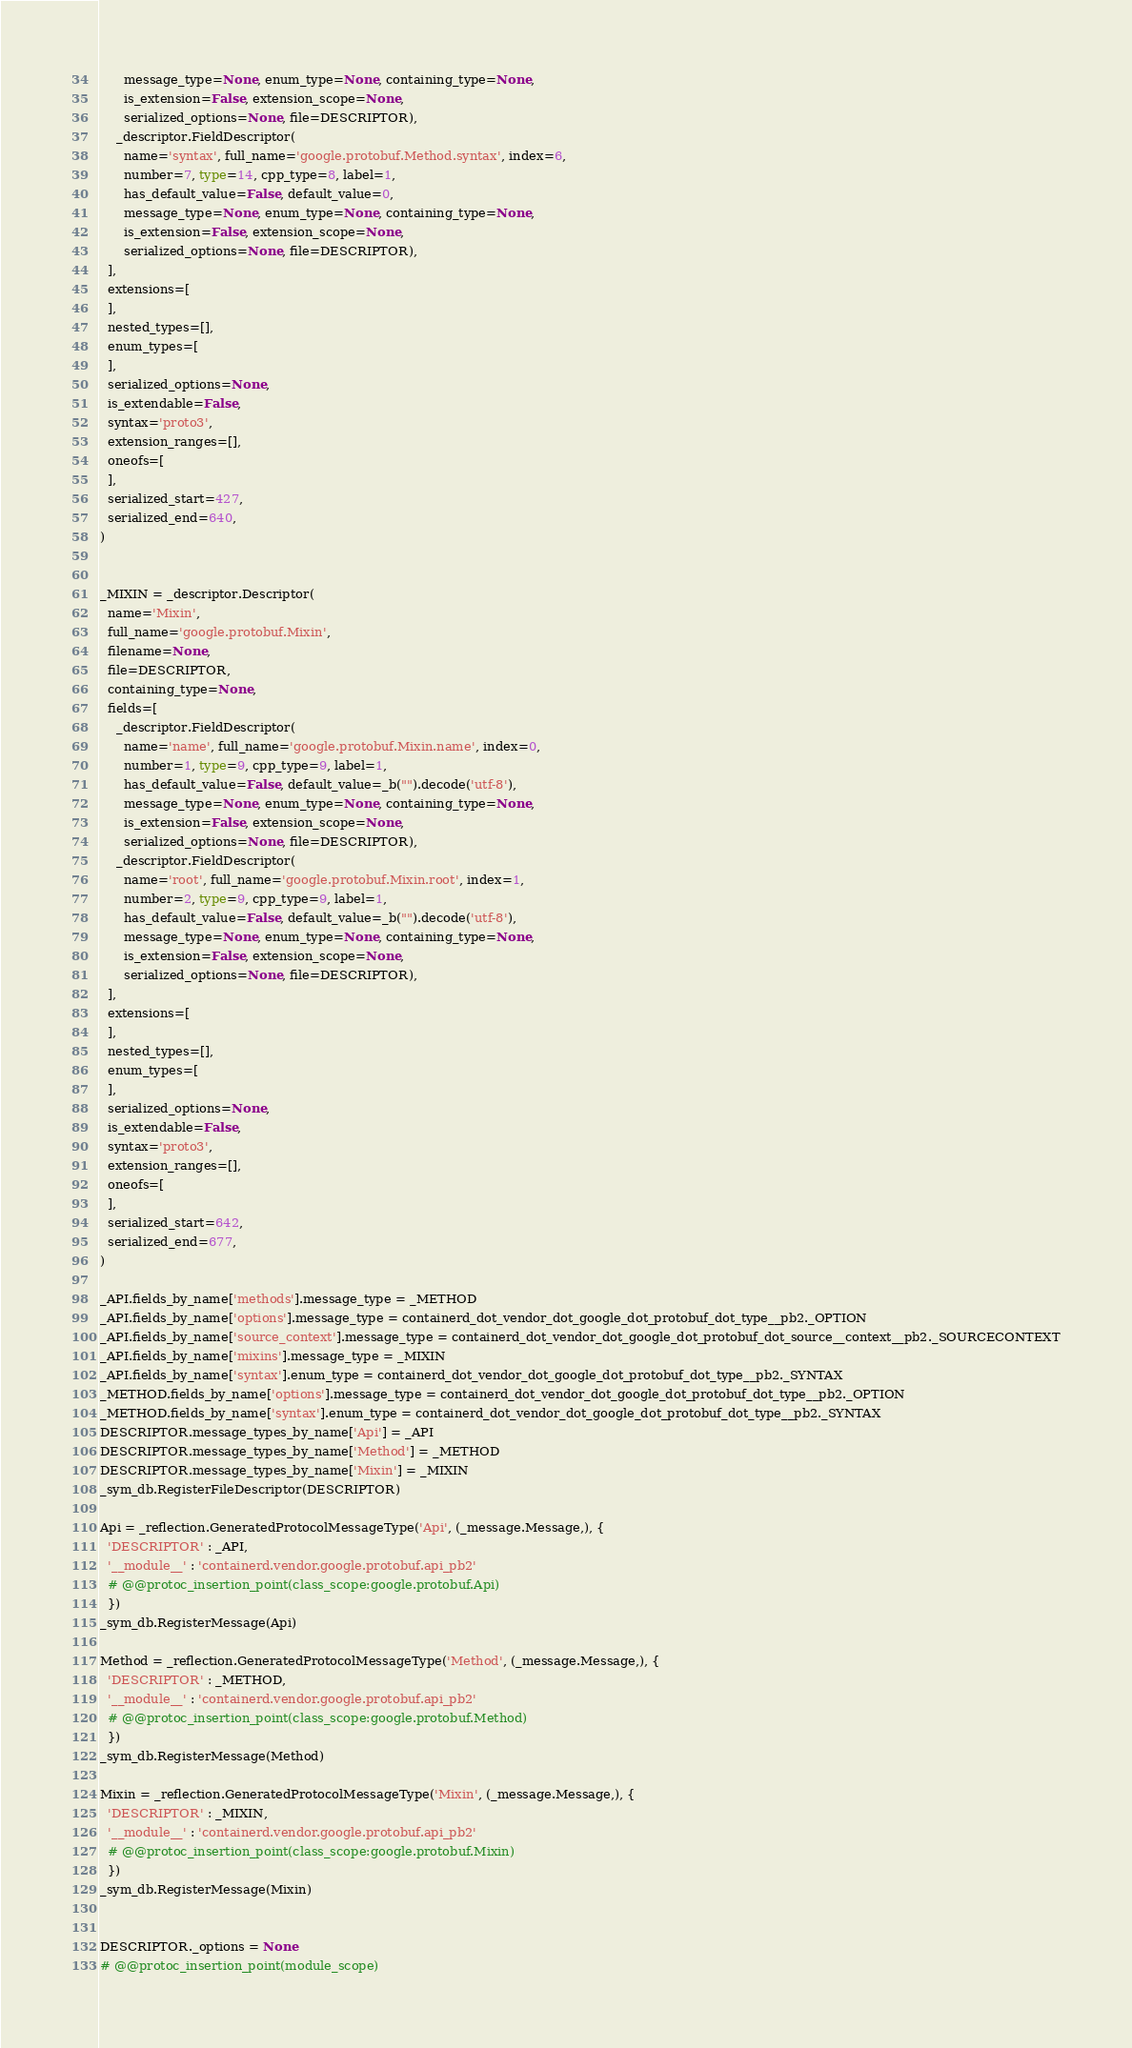Convert code to text. <code><loc_0><loc_0><loc_500><loc_500><_Python_>      message_type=None, enum_type=None, containing_type=None,
      is_extension=False, extension_scope=None,
      serialized_options=None, file=DESCRIPTOR),
    _descriptor.FieldDescriptor(
      name='syntax', full_name='google.protobuf.Method.syntax', index=6,
      number=7, type=14, cpp_type=8, label=1,
      has_default_value=False, default_value=0,
      message_type=None, enum_type=None, containing_type=None,
      is_extension=False, extension_scope=None,
      serialized_options=None, file=DESCRIPTOR),
  ],
  extensions=[
  ],
  nested_types=[],
  enum_types=[
  ],
  serialized_options=None,
  is_extendable=False,
  syntax='proto3',
  extension_ranges=[],
  oneofs=[
  ],
  serialized_start=427,
  serialized_end=640,
)


_MIXIN = _descriptor.Descriptor(
  name='Mixin',
  full_name='google.protobuf.Mixin',
  filename=None,
  file=DESCRIPTOR,
  containing_type=None,
  fields=[
    _descriptor.FieldDescriptor(
      name='name', full_name='google.protobuf.Mixin.name', index=0,
      number=1, type=9, cpp_type=9, label=1,
      has_default_value=False, default_value=_b("").decode('utf-8'),
      message_type=None, enum_type=None, containing_type=None,
      is_extension=False, extension_scope=None,
      serialized_options=None, file=DESCRIPTOR),
    _descriptor.FieldDescriptor(
      name='root', full_name='google.protobuf.Mixin.root', index=1,
      number=2, type=9, cpp_type=9, label=1,
      has_default_value=False, default_value=_b("").decode('utf-8'),
      message_type=None, enum_type=None, containing_type=None,
      is_extension=False, extension_scope=None,
      serialized_options=None, file=DESCRIPTOR),
  ],
  extensions=[
  ],
  nested_types=[],
  enum_types=[
  ],
  serialized_options=None,
  is_extendable=False,
  syntax='proto3',
  extension_ranges=[],
  oneofs=[
  ],
  serialized_start=642,
  serialized_end=677,
)

_API.fields_by_name['methods'].message_type = _METHOD
_API.fields_by_name['options'].message_type = containerd_dot_vendor_dot_google_dot_protobuf_dot_type__pb2._OPTION
_API.fields_by_name['source_context'].message_type = containerd_dot_vendor_dot_google_dot_protobuf_dot_source__context__pb2._SOURCECONTEXT
_API.fields_by_name['mixins'].message_type = _MIXIN
_API.fields_by_name['syntax'].enum_type = containerd_dot_vendor_dot_google_dot_protobuf_dot_type__pb2._SYNTAX
_METHOD.fields_by_name['options'].message_type = containerd_dot_vendor_dot_google_dot_protobuf_dot_type__pb2._OPTION
_METHOD.fields_by_name['syntax'].enum_type = containerd_dot_vendor_dot_google_dot_protobuf_dot_type__pb2._SYNTAX
DESCRIPTOR.message_types_by_name['Api'] = _API
DESCRIPTOR.message_types_by_name['Method'] = _METHOD
DESCRIPTOR.message_types_by_name['Mixin'] = _MIXIN
_sym_db.RegisterFileDescriptor(DESCRIPTOR)

Api = _reflection.GeneratedProtocolMessageType('Api', (_message.Message,), {
  'DESCRIPTOR' : _API,
  '__module__' : 'containerd.vendor.google.protobuf.api_pb2'
  # @@protoc_insertion_point(class_scope:google.protobuf.Api)
  })
_sym_db.RegisterMessage(Api)

Method = _reflection.GeneratedProtocolMessageType('Method', (_message.Message,), {
  'DESCRIPTOR' : _METHOD,
  '__module__' : 'containerd.vendor.google.protobuf.api_pb2'
  # @@protoc_insertion_point(class_scope:google.protobuf.Method)
  })
_sym_db.RegisterMessage(Method)

Mixin = _reflection.GeneratedProtocolMessageType('Mixin', (_message.Message,), {
  'DESCRIPTOR' : _MIXIN,
  '__module__' : 'containerd.vendor.google.protobuf.api_pb2'
  # @@protoc_insertion_point(class_scope:google.protobuf.Mixin)
  })
_sym_db.RegisterMessage(Mixin)


DESCRIPTOR._options = None
# @@protoc_insertion_point(module_scope)
</code> 